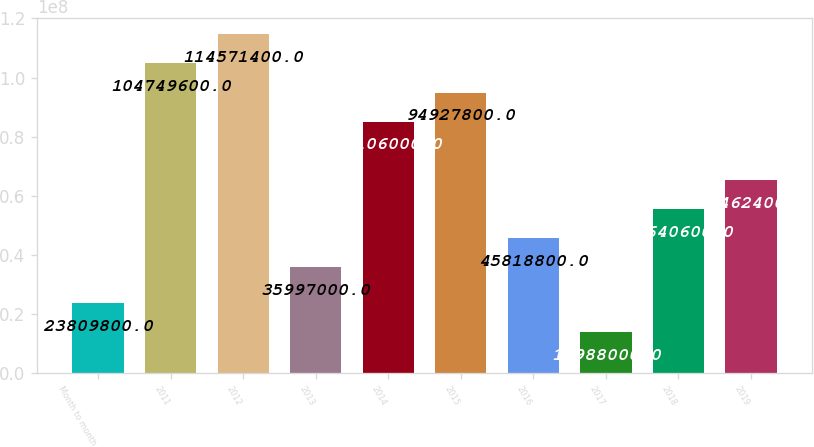Convert chart. <chart><loc_0><loc_0><loc_500><loc_500><bar_chart><fcel>Month to month<fcel>2011<fcel>2012<fcel>2013<fcel>2014<fcel>2015<fcel>2016<fcel>2017<fcel>2018<fcel>2019<nl><fcel>2.38098e+07<fcel>1.0475e+08<fcel>1.14571e+08<fcel>3.5997e+07<fcel>8.5106e+07<fcel>9.49278e+07<fcel>4.58188e+07<fcel>1.3988e+07<fcel>5.56406e+07<fcel>6.54624e+07<nl></chart> 